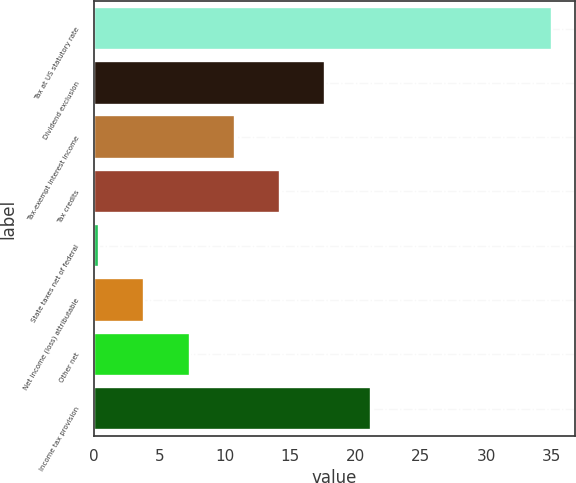Convert chart to OTSL. <chart><loc_0><loc_0><loc_500><loc_500><bar_chart><fcel>Tax at US statutory rate<fcel>Dividend exclusion<fcel>Tax-exempt interest income<fcel>Tax credits<fcel>State taxes net of federal<fcel>Net income (loss) attributable<fcel>Other net<fcel>Income tax provision<nl><fcel>35<fcel>17.7<fcel>10.78<fcel>14.24<fcel>0.4<fcel>3.86<fcel>7.32<fcel>21.16<nl></chart> 